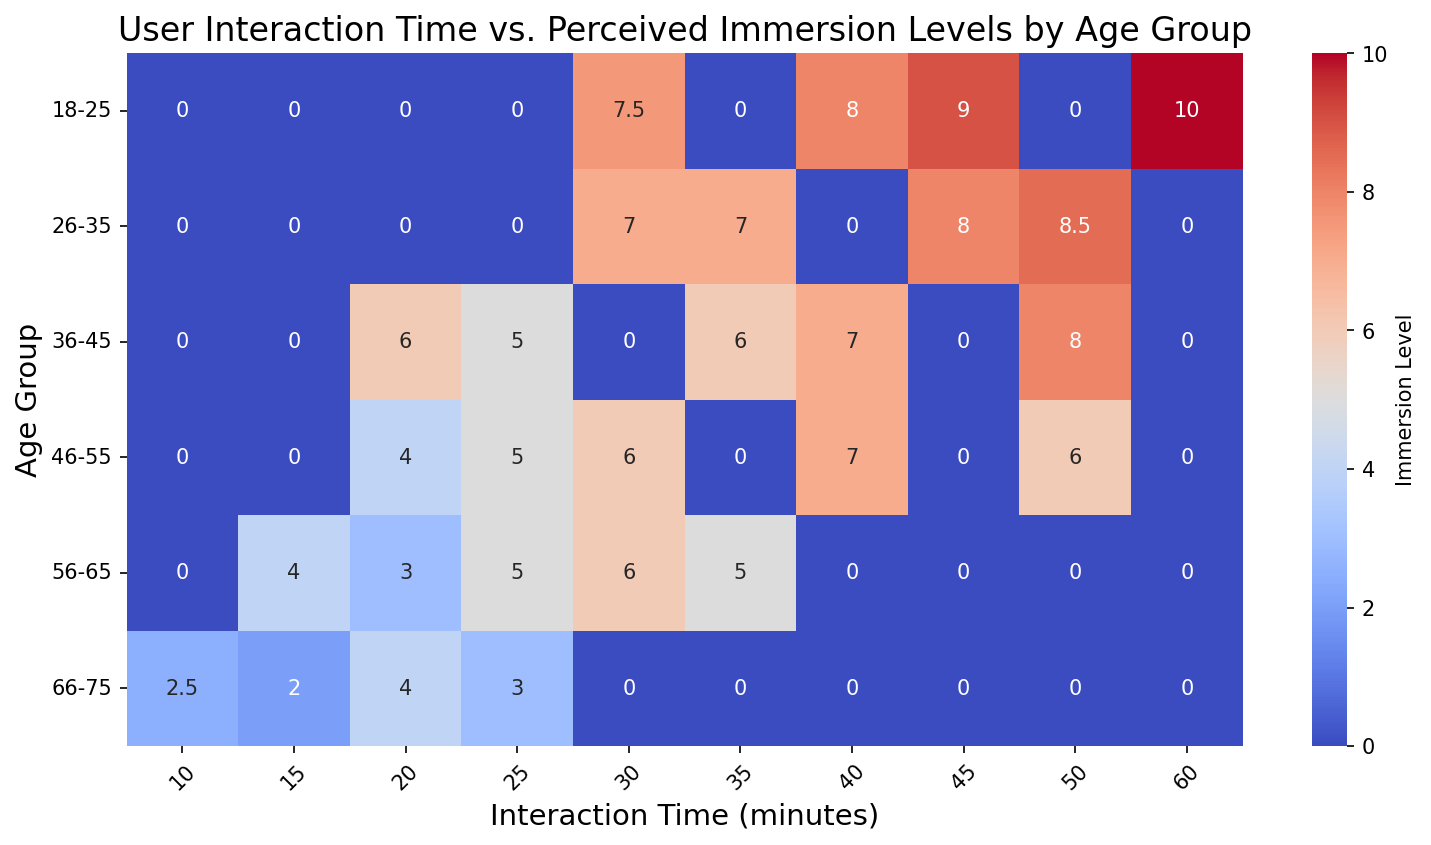What is the perceived immersion level for the age group 18-25 with 60 minutes of interaction time? Locate the cell where the “Age Group” is 18-25 and “Interaction Time” is 60 minutes. The value in this cell represents the perceived immersion level.
Answer: 10 Which age group has the highest perceived immersion level with 40 minutes of interaction time? Compare the values in the column where the “Interaction Time” is 40 minutes across all rows (age groups). Identify the highest value and the corresponding age group.
Answer: 26-35 Among the age group 46-55, what is the average perceived immersion level across all interaction times? Extract all values in the row where "Age Group" is 46-55. Calculate the average of these values: (5 + 6 + 7 + 6 + 4)/5 = 28/5.
Answer: 5.6 What is the difference in perceived immersion levels between the 18-25 age group and the 36-45 age group with 30 minutes of interaction time? Identify the perceived immersion levels for 18-25 (value = 7.5 for overlapping data points) and 36-45 (value = 0) for 30 minutes from the heatmap. Subtract the value for 36-45 from the value for 18-25: 7.5 - 0 = 7.5.
Answer: 7.5 Which interaction time yields the highest average perceived immersion level for the age group 26-35? Locate and sum the perceived immersion levels for all interaction times in the 26-35 row: (7 + 0 + 7 + 0 + 8.5)/5. The interaction time that contributes to the highest sum/average will be the answer.
Answer: 50 minutes What is the color representing the immersion level of 3 for the age group 66-75 with 10 minutes of interaction time? Identify the cell in the heatmap where the corresponding values intersect. Observe the color fill of that cell.
Answer: Light blue In terms of perceived immersion levels at 30 minutes of interaction time, which age group has the lowest value and what is it? Compare the perceived immersion levels across different age groups for the interaction time of 30 minutes. Find the lowest value and its corresponding age group.
Answer: 56-65 and 5 Is the perceived immersion level generally increasing or decreasing with age for 20 minutes of interaction time? Compare the perceived immersion levels in cells corresponding to the 20 minutes interaction time across increasing age groups. Observe the trend.
Answer: Decreasing What interaction time shows a median perceived immersion level of 7 for the age group 36-45? Look at the values in the row for 36-45 and identify the interaction time that shows the value 7. The median of (6, 7, 6, 8, 5) ordered is 7.
Answer: 40 and 50 minutes 